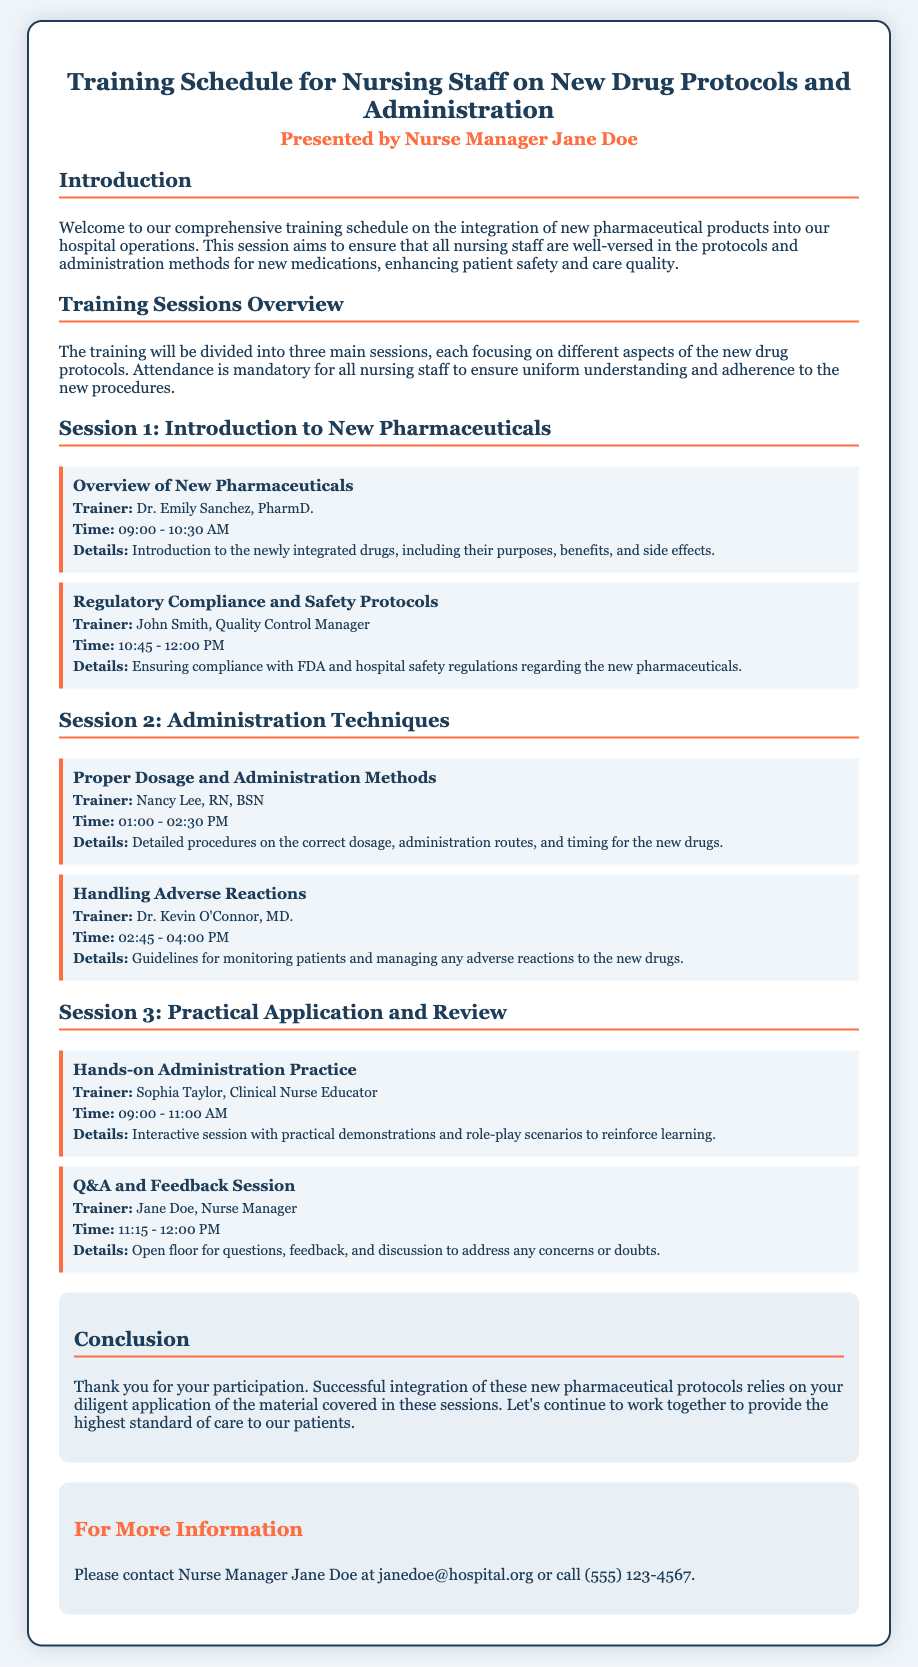What is the title of the training schedule? The title of the training schedule is found in the header of the document.
Answer: Training Schedule for Nursing Staff on New Drug Protocols and Administration Who is the presenter of the training? The presenter's name is indicated beneath the title.
Answer: Nurse Manager Jane Doe What time does the first training session start? The start time for the first session is specified in the schedule section.
Answer: 09:00 AM Which trainer will cover the topic of handling adverse reactions? The trainer's name for this topic is listed under Session 2.
Answer: Dr. Kevin O'Connor What is the main theme of Session 3? The theme of this session is described under its header.
Answer: Practical Application and Review What is the purpose of the conclusion section? The conclusion section summarizes the objectives of the training.
Answer: Successful integration of new pharmaceutical protocols How long is the Q&A and Feedback session? The duration of this session is mentioned in its details.
Answer: 45 minutes Which method is emphasized for reinforcing learning in the practical session? The reinforcement method is described in the details of the hands-on practice topic.
Answer: Role-play scenarios Who should attendees contact for more information? The contact person is provided in the last section of the document.
Answer: Nurse Manager Jane Doe 